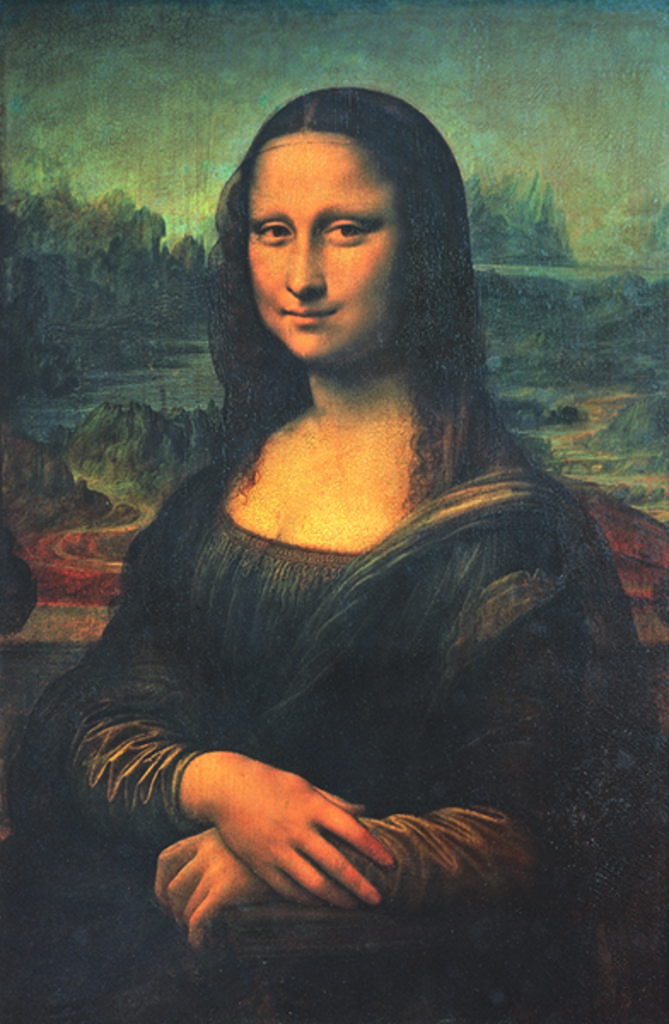How would you summarize this image in a sentence or two? In this image, we can see a photo, in that photo we can see a woman standing. 